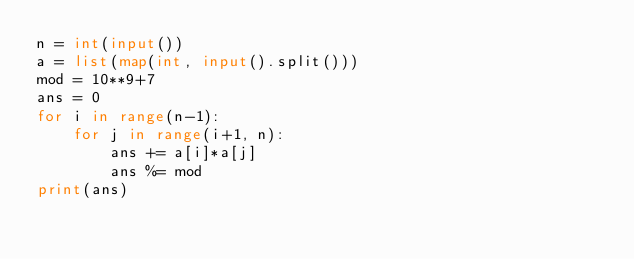Convert code to text. <code><loc_0><loc_0><loc_500><loc_500><_Python_>n = int(input())
a = list(map(int, input().split()))
mod = 10**9+7
ans = 0
for i in range(n-1):
    for j in range(i+1, n):
        ans += a[i]*a[j]
        ans %= mod
print(ans)
</code> 